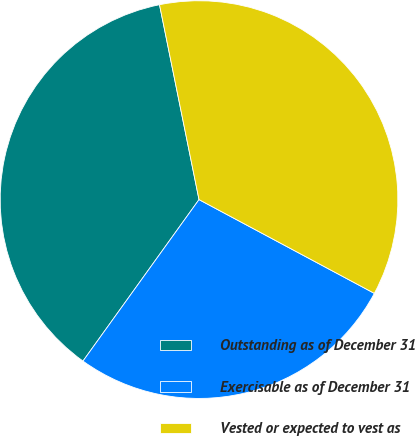Convert chart to OTSL. <chart><loc_0><loc_0><loc_500><loc_500><pie_chart><fcel>Outstanding as of December 31<fcel>Exercisable as of December 31<fcel>Vested or expected to vest as<nl><fcel>36.9%<fcel>27.1%<fcel>36.0%<nl></chart> 